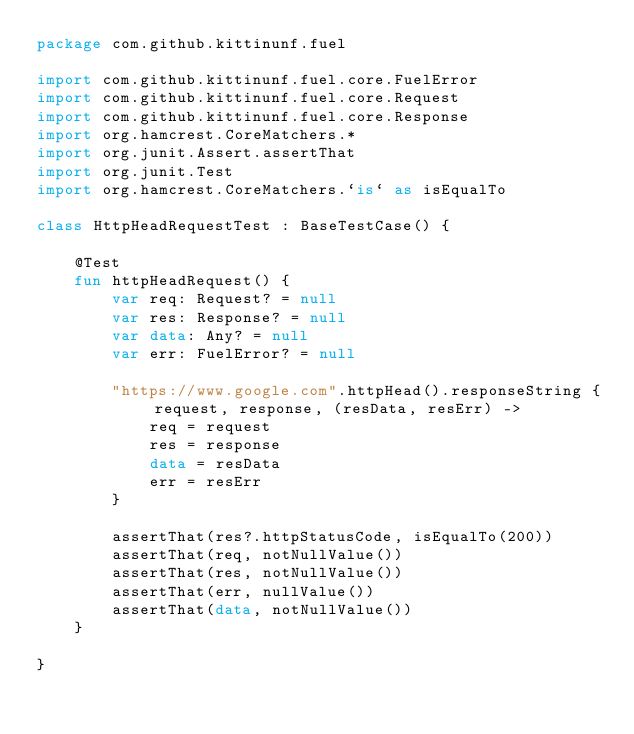<code> <loc_0><loc_0><loc_500><loc_500><_Kotlin_>package com.github.kittinunf.fuel

import com.github.kittinunf.fuel.core.FuelError
import com.github.kittinunf.fuel.core.Request
import com.github.kittinunf.fuel.core.Response
import org.hamcrest.CoreMatchers.*
import org.junit.Assert.assertThat
import org.junit.Test
import org.hamcrest.CoreMatchers.`is` as isEqualTo

class HttpHeadRequestTest : BaseTestCase() {

    @Test
    fun httpHeadRequest() {
        var req: Request? = null
        var res: Response? = null
        var data: Any? = null
        var err: FuelError? = null

        "https://www.google.com".httpHead().responseString { request, response, (resData, resErr) ->
            req = request
            res = response
            data = resData
            err = resErr
        }

        assertThat(res?.httpStatusCode, isEqualTo(200))
        assertThat(req, notNullValue())
        assertThat(res, notNullValue())
        assertThat(err, nullValue())
        assertThat(data, notNullValue())
    }

}</code> 